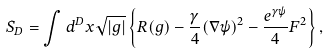Convert formula to latex. <formula><loc_0><loc_0><loc_500><loc_500>S _ { D } = \int d ^ { D } x \sqrt { | g | } \left \{ R ( g ) - \frac { \gamma } 4 ( \nabla \psi ) ^ { 2 } - \frac { e ^ { \gamma \psi } } 4 F ^ { 2 } \right \} ,</formula> 